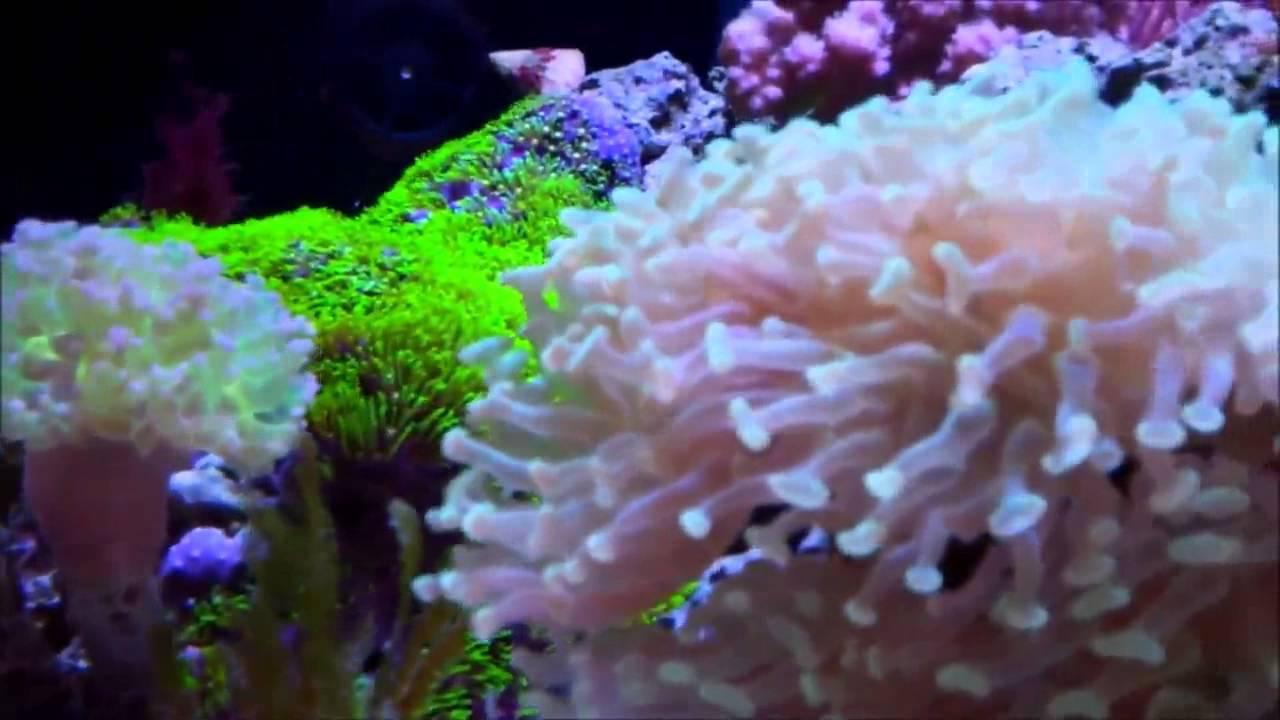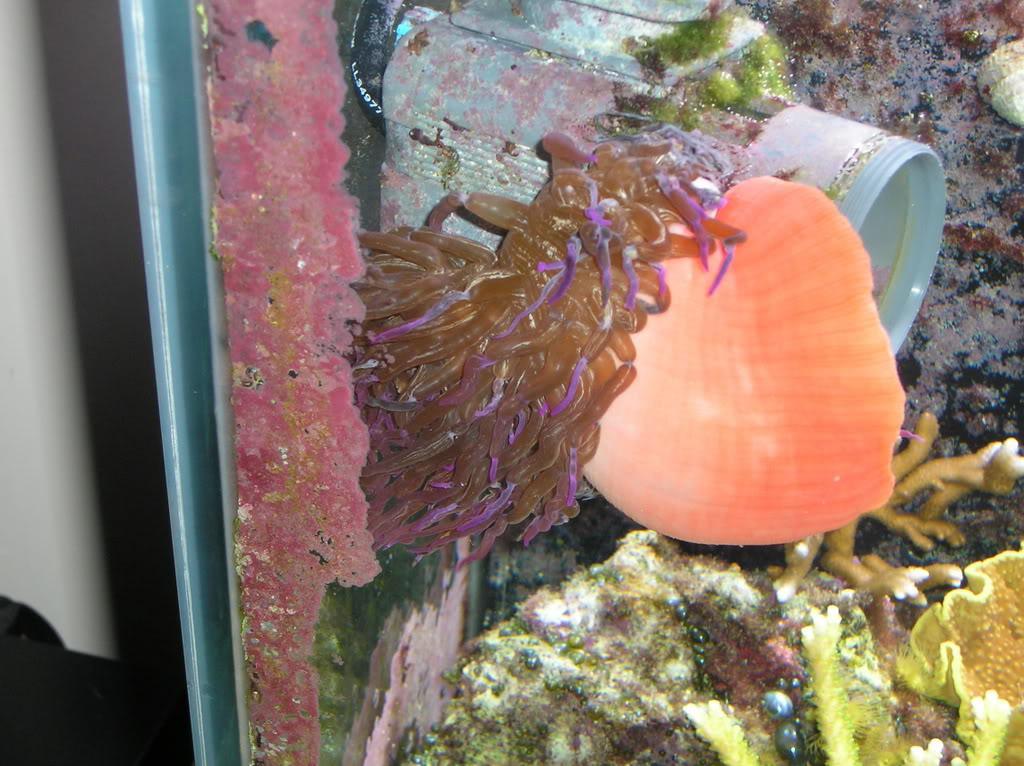The first image is the image on the left, the second image is the image on the right. Assess this claim about the two images: "In at least one image there is a fish tank holding at least one fish.". Correct or not? Answer yes or no. Yes. 